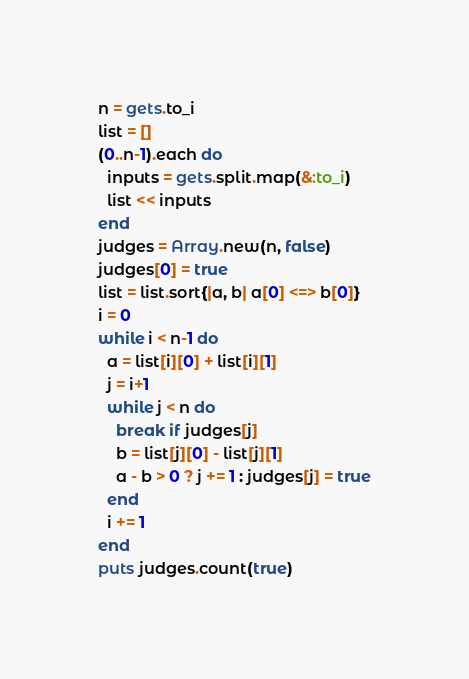<code> <loc_0><loc_0><loc_500><loc_500><_Ruby_>n = gets.to_i
list = []
(0..n-1).each do
  inputs = gets.split.map(&:to_i)
  list << inputs
end
judges = Array.new(n, false)
judges[0] = true
list = list.sort{|a, b| a[0] <=> b[0]}
i = 0
while i < n-1 do
  a = list[i][0] + list[i][1]
  j = i+1
  while j < n do
    break if judges[j]
    b = list[j][0] - list[j][1]
    a - b > 0 ? j += 1 : judges[j] = true
  end
  i += 1
end
puts judges.count(true)
</code> 